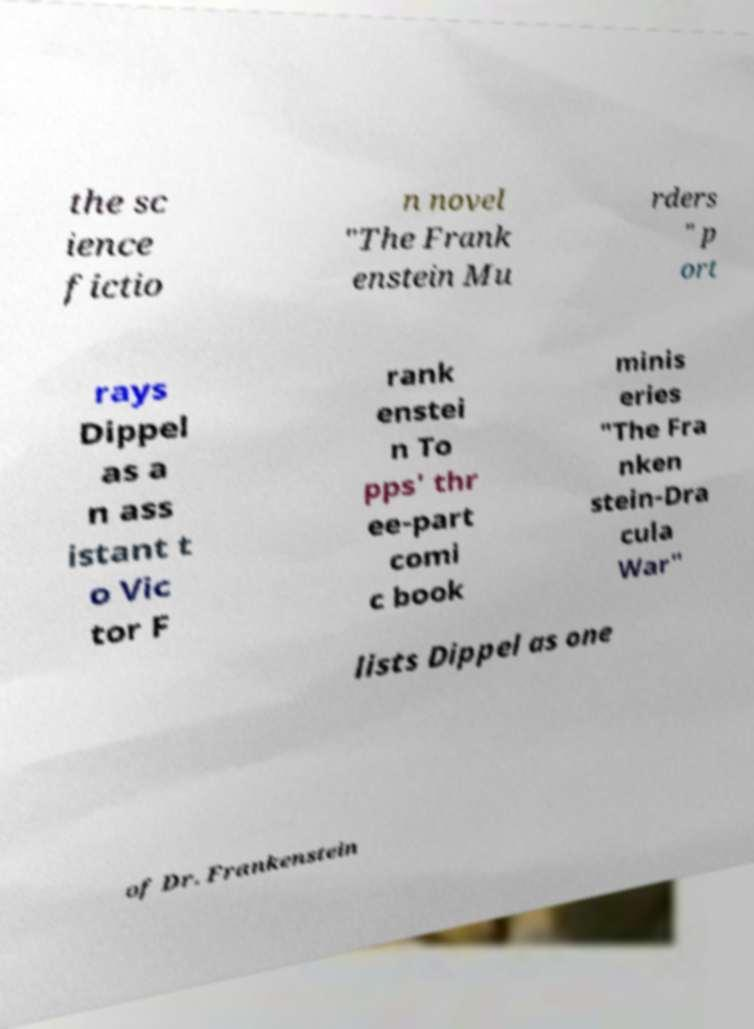Please identify and transcribe the text found in this image. the sc ience fictio n novel "The Frank enstein Mu rders " p ort rays Dippel as a n ass istant t o Vic tor F rank enstei n To pps' thr ee-part comi c book minis eries "The Fra nken stein-Dra cula War" lists Dippel as one of Dr. Frankenstein 